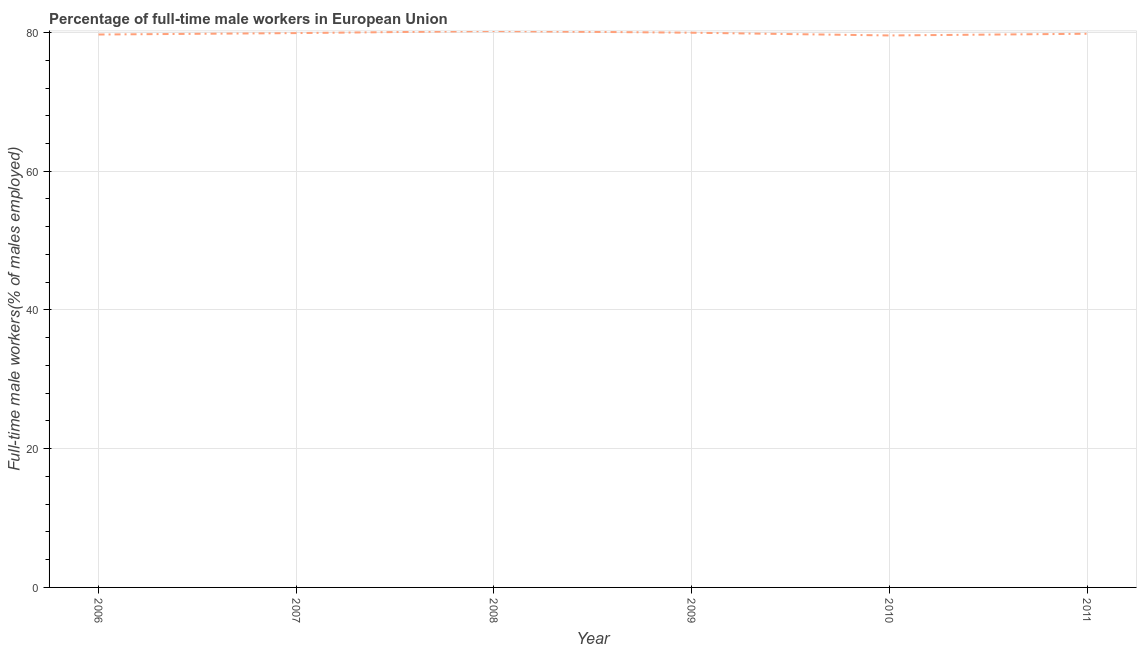What is the percentage of full-time male workers in 2009?
Your answer should be very brief. 79.97. Across all years, what is the maximum percentage of full-time male workers?
Give a very brief answer. 80.21. Across all years, what is the minimum percentage of full-time male workers?
Your answer should be very brief. 79.58. In which year was the percentage of full-time male workers maximum?
Make the answer very short. 2008. What is the sum of the percentage of full-time male workers?
Provide a short and direct response. 479.22. What is the difference between the percentage of full-time male workers in 2006 and 2011?
Offer a very short reply. -0.11. What is the average percentage of full-time male workers per year?
Keep it short and to the point. 79.87. What is the median percentage of full-time male workers?
Your response must be concise. 79.87. In how many years, is the percentage of full-time male workers greater than 64 %?
Keep it short and to the point. 6. What is the ratio of the percentage of full-time male workers in 2010 to that in 2011?
Keep it short and to the point. 1. What is the difference between the highest and the second highest percentage of full-time male workers?
Your response must be concise. 0.24. What is the difference between the highest and the lowest percentage of full-time male workers?
Make the answer very short. 0.63. Does the percentage of full-time male workers monotonically increase over the years?
Your answer should be compact. No. How many lines are there?
Ensure brevity in your answer.  1. Are the values on the major ticks of Y-axis written in scientific E-notation?
Give a very brief answer. No. Does the graph contain grids?
Your answer should be compact. Yes. What is the title of the graph?
Provide a succinct answer. Percentage of full-time male workers in European Union. What is the label or title of the X-axis?
Offer a terse response. Year. What is the label or title of the Y-axis?
Your answer should be very brief. Full-time male workers(% of males employed). What is the Full-time male workers(% of males employed) in 2006?
Your answer should be very brief. 79.71. What is the Full-time male workers(% of males employed) of 2007?
Your answer should be very brief. 79.92. What is the Full-time male workers(% of males employed) in 2008?
Your answer should be compact. 80.21. What is the Full-time male workers(% of males employed) of 2009?
Your response must be concise. 79.97. What is the Full-time male workers(% of males employed) of 2010?
Your answer should be compact. 79.58. What is the Full-time male workers(% of males employed) of 2011?
Give a very brief answer. 79.82. What is the difference between the Full-time male workers(% of males employed) in 2006 and 2007?
Keep it short and to the point. -0.21. What is the difference between the Full-time male workers(% of males employed) in 2006 and 2008?
Offer a terse response. -0.5. What is the difference between the Full-time male workers(% of males employed) in 2006 and 2009?
Offer a very short reply. -0.26. What is the difference between the Full-time male workers(% of males employed) in 2006 and 2010?
Make the answer very short. 0.13. What is the difference between the Full-time male workers(% of males employed) in 2006 and 2011?
Make the answer very short. -0.11. What is the difference between the Full-time male workers(% of males employed) in 2007 and 2008?
Provide a short and direct response. -0.3. What is the difference between the Full-time male workers(% of males employed) in 2007 and 2009?
Ensure brevity in your answer.  -0.05. What is the difference between the Full-time male workers(% of males employed) in 2007 and 2010?
Provide a succinct answer. 0.34. What is the difference between the Full-time male workers(% of males employed) in 2007 and 2011?
Ensure brevity in your answer.  0.1. What is the difference between the Full-time male workers(% of males employed) in 2008 and 2009?
Your answer should be compact. 0.24. What is the difference between the Full-time male workers(% of males employed) in 2008 and 2010?
Provide a succinct answer. 0.63. What is the difference between the Full-time male workers(% of males employed) in 2008 and 2011?
Your answer should be compact. 0.39. What is the difference between the Full-time male workers(% of males employed) in 2009 and 2010?
Offer a terse response. 0.39. What is the difference between the Full-time male workers(% of males employed) in 2009 and 2011?
Provide a short and direct response. 0.15. What is the difference between the Full-time male workers(% of males employed) in 2010 and 2011?
Your answer should be very brief. -0.24. What is the ratio of the Full-time male workers(% of males employed) in 2006 to that in 2007?
Give a very brief answer. 1. What is the ratio of the Full-time male workers(% of males employed) in 2006 to that in 2008?
Give a very brief answer. 0.99. What is the ratio of the Full-time male workers(% of males employed) in 2006 to that in 2009?
Offer a very short reply. 1. What is the ratio of the Full-time male workers(% of males employed) in 2006 to that in 2011?
Your response must be concise. 1. What is the ratio of the Full-time male workers(% of males employed) in 2007 to that in 2011?
Your answer should be very brief. 1. What is the ratio of the Full-time male workers(% of males employed) in 2008 to that in 2009?
Keep it short and to the point. 1. What is the ratio of the Full-time male workers(% of males employed) in 2008 to that in 2011?
Provide a succinct answer. 1. What is the ratio of the Full-time male workers(% of males employed) in 2009 to that in 2010?
Offer a terse response. 1. What is the ratio of the Full-time male workers(% of males employed) in 2009 to that in 2011?
Offer a terse response. 1. 